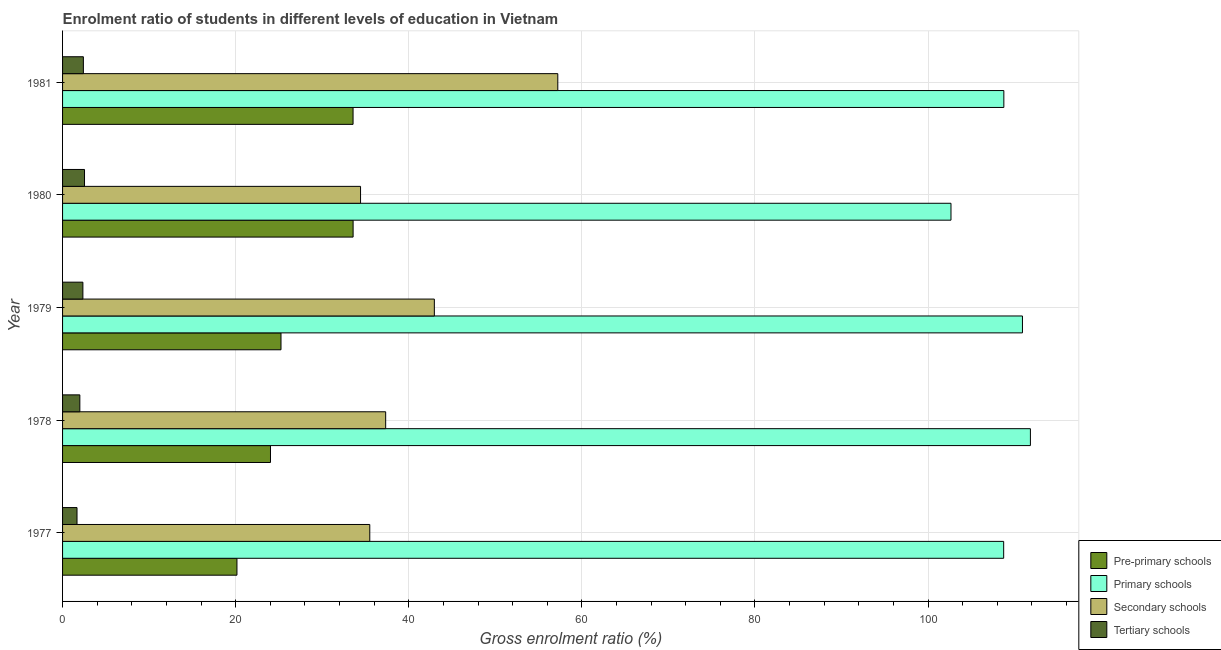How many groups of bars are there?
Your answer should be compact. 5. What is the label of the 3rd group of bars from the top?
Offer a very short reply. 1979. In how many cases, is the number of bars for a given year not equal to the number of legend labels?
Ensure brevity in your answer.  0. What is the gross enrolment ratio in primary schools in 1980?
Make the answer very short. 102.65. Across all years, what is the maximum gross enrolment ratio in pre-primary schools?
Offer a very short reply. 33.57. Across all years, what is the minimum gross enrolment ratio in primary schools?
Offer a terse response. 102.65. In which year was the gross enrolment ratio in secondary schools maximum?
Offer a terse response. 1981. What is the total gross enrolment ratio in pre-primary schools in the graph?
Your answer should be compact. 136.55. What is the difference between the gross enrolment ratio in primary schools in 1977 and that in 1978?
Offer a very short reply. -3.09. What is the difference between the gross enrolment ratio in tertiary schools in 1977 and the gross enrolment ratio in pre-primary schools in 1978?
Your answer should be very brief. -22.35. What is the average gross enrolment ratio in pre-primary schools per year?
Provide a short and direct response. 27.31. In the year 1979, what is the difference between the gross enrolment ratio in pre-primary schools and gross enrolment ratio in tertiary schools?
Provide a short and direct response. 22.89. What is the ratio of the gross enrolment ratio in pre-primary schools in 1980 to that in 1981?
Provide a short and direct response. 1. What is the difference between the highest and the second highest gross enrolment ratio in secondary schools?
Ensure brevity in your answer.  14.26. What is the difference between the highest and the lowest gross enrolment ratio in primary schools?
Your answer should be very brief. 9.18. In how many years, is the gross enrolment ratio in tertiary schools greater than the average gross enrolment ratio in tertiary schools taken over all years?
Keep it short and to the point. 3. Is the sum of the gross enrolment ratio in pre-primary schools in 1977 and 1980 greater than the maximum gross enrolment ratio in secondary schools across all years?
Provide a succinct answer. No. Is it the case that in every year, the sum of the gross enrolment ratio in secondary schools and gross enrolment ratio in tertiary schools is greater than the sum of gross enrolment ratio in pre-primary schools and gross enrolment ratio in primary schools?
Keep it short and to the point. No. What does the 2nd bar from the top in 1980 represents?
Your answer should be compact. Secondary schools. What does the 2nd bar from the bottom in 1980 represents?
Your response must be concise. Primary schools. How many bars are there?
Offer a very short reply. 20. How many years are there in the graph?
Ensure brevity in your answer.  5. What is the difference between two consecutive major ticks on the X-axis?
Provide a short and direct response. 20. Are the values on the major ticks of X-axis written in scientific E-notation?
Your answer should be compact. No. Does the graph contain any zero values?
Offer a very short reply. No. Does the graph contain grids?
Your answer should be very brief. Yes. How many legend labels are there?
Provide a short and direct response. 4. What is the title of the graph?
Keep it short and to the point. Enrolment ratio of students in different levels of education in Vietnam. Does "Coal" appear as one of the legend labels in the graph?
Provide a short and direct response. No. What is the label or title of the X-axis?
Your answer should be compact. Gross enrolment ratio (%). What is the Gross enrolment ratio (%) in Pre-primary schools in 1977?
Keep it short and to the point. 20.15. What is the Gross enrolment ratio (%) in Primary schools in 1977?
Offer a terse response. 108.74. What is the Gross enrolment ratio (%) of Secondary schools in 1977?
Offer a terse response. 35.5. What is the Gross enrolment ratio (%) in Tertiary schools in 1977?
Give a very brief answer. 1.67. What is the Gross enrolment ratio (%) in Pre-primary schools in 1978?
Your answer should be very brief. 24.02. What is the Gross enrolment ratio (%) in Primary schools in 1978?
Offer a terse response. 111.83. What is the Gross enrolment ratio (%) of Secondary schools in 1978?
Your answer should be compact. 37.33. What is the Gross enrolment ratio (%) of Tertiary schools in 1978?
Offer a terse response. 2. What is the Gross enrolment ratio (%) in Pre-primary schools in 1979?
Make the answer very short. 25.24. What is the Gross enrolment ratio (%) in Primary schools in 1979?
Your response must be concise. 110.91. What is the Gross enrolment ratio (%) of Secondary schools in 1979?
Your response must be concise. 42.96. What is the Gross enrolment ratio (%) of Tertiary schools in 1979?
Offer a very short reply. 2.35. What is the Gross enrolment ratio (%) of Pre-primary schools in 1980?
Offer a terse response. 33.57. What is the Gross enrolment ratio (%) of Primary schools in 1980?
Make the answer very short. 102.65. What is the Gross enrolment ratio (%) of Secondary schools in 1980?
Keep it short and to the point. 34.43. What is the Gross enrolment ratio (%) of Tertiary schools in 1980?
Keep it short and to the point. 2.54. What is the Gross enrolment ratio (%) in Pre-primary schools in 1981?
Your answer should be compact. 33.56. What is the Gross enrolment ratio (%) in Primary schools in 1981?
Make the answer very short. 108.76. What is the Gross enrolment ratio (%) in Secondary schools in 1981?
Make the answer very short. 57.22. What is the Gross enrolment ratio (%) in Tertiary schools in 1981?
Offer a very short reply. 2.4. Across all years, what is the maximum Gross enrolment ratio (%) of Pre-primary schools?
Ensure brevity in your answer.  33.57. Across all years, what is the maximum Gross enrolment ratio (%) of Primary schools?
Offer a terse response. 111.83. Across all years, what is the maximum Gross enrolment ratio (%) in Secondary schools?
Offer a very short reply. 57.22. Across all years, what is the maximum Gross enrolment ratio (%) in Tertiary schools?
Your answer should be compact. 2.54. Across all years, what is the minimum Gross enrolment ratio (%) in Pre-primary schools?
Ensure brevity in your answer.  20.15. Across all years, what is the minimum Gross enrolment ratio (%) in Primary schools?
Provide a short and direct response. 102.65. Across all years, what is the minimum Gross enrolment ratio (%) in Secondary schools?
Offer a terse response. 34.43. Across all years, what is the minimum Gross enrolment ratio (%) in Tertiary schools?
Keep it short and to the point. 1.67. What is the total Gross enrolment ratio (%) in Pre-primary schools in the graph?
Provide a succinct answer. 136.55. What is the total Gross enrolment ratio (%) of Primary schools in the graph?
Provide a short and direct response. 542.88. What is the total Gross enrolment ratio (%) of Secondary schools in the graph?
Provide a short and direct response. 207.44. What is the total Gross enrolment ratio (%) of Tertiary schools in the graph?
Provide a succinct answer. 10.95. What is the difference between the Gross enrolment ratio (%) of Pre-primary schools in 1977 and that in 1978?
Provide a succinct answer. -3.87. What is the difference between the Gross enrolment ratio (%) of Primary schools in 1977 and that in 1978?
Your response must be concise. -3.09. What is the difference between the Gross enrolment ratio (%) in Secondary schools in 1977 and that in 1978?
Give a very brief answer. -1.84. What is the difference between the Gross enrolment ratio (%) of Tertiary schools in 1977 and that in 1978?
Your answer should be very brief. -0.33. What is the difference between the Gross enrolment ratio (%) of Pre-primary schools in 1977 and that in 1979?
Offer a very short reply. -5.09. What is the difference between the Gross enrolment ratio (%) in Primary schools in 1977 and that in 1979?
Your answer should be compact. -2.17. What is the difference between the Gross enrolment ratio (%) of Secondary schools in 1977 and that in 1979?
Offer a terse response. -7.46. What is the difference between the Gross enrolment ratio (%) in Tertiary schools in 1977 and that in 1979?
Provide a short and direct response. -0.68. What is the difference between the Gross enrolment ratio (%) in Pre-primary schools in 1977 and that in 1980?
Your answer should be very brief. -13.42. What is the difference between the Gross enrolment ratio (%) of Primary schools in 1977 and that in 1980?
Ensure brevity in your answer.  6.09. What is the difference between the Gross enrolment ratio (%) in Secondary schools in 1977 and that in 1980?
Keep it short and to the point. 1.07. What is the difference between the Gross enrolment ratio (%) of Tertiary schools in 1977 and that in 1980?
Your response must be concise. -0.87. What is the difference between the Gross enrolment ratio (%) in Pre-primary schools in 1977 and that in 1981?
Your answer should be compact. -13.42. What is the difference between the Gross enrolment ratio (%) of Primary schools in 1977 and that in 1981?
Provide a short and direct response. -0.02. What is the difference between the Gross enrolment ratio (%) in Secondary schools in 1977 and that in 1981?
Your response must be concise. -21.72. What is the difference between the Gross enrolment ratio (%) of Tertiary schools in 1977 and that in 1981?
Provide a succinct answer. -0.73. What is the difference between the Gross enrolment ratio (%) in Pre-primary schools in 1978 and that in 1979?
Keep it short and to the point. -1.22. What is the difference between the Gross enrolment ratio (%) of Primary schools in 1978 and that in 1979?
Offer a terse response. 0.92. What is the difference between the Gross enrolment ratio (%) in Secondary schools in 1978 and that in 1979?
Offer a terse response. -5.62. What is the difference between the Gross enrolment ratio (%) in Tertiary schools in 1978 and that in 1979?
Provide a succinct answer. -0.35. What is the difference between the Gross enrolment ratio (%) in Pre-primary schools in 1978 and that in 1980?
Provide a succinct answer. -9.55. What is the difference between the Gross enrolment ratio (%) of Primary schools in 1978 and that in 1980?
Provide a short and direct response. 9.18. What is the difference between the Gross enrolment ratio (%) in Secondary schools in 1978 and that in 1980?
Offer a terse response. 2.9. What is the difference between the Gross enrolment ratio (%) in Tertiary schools in 1978 and that in 1980?
Give a very brief answer. -0.54. What is the difference between the Gross enrolment ratio (%) of Pre-primary schools in 1978 and that in 1981?
Give a very brief answer. -9.54. What is the difference between the Gross enrolment ratio (%) in Primary schools in 1978 and that in 1981?
Make the answer very short. 3.07. What is the difference between the Gross enrolment ratio (%) of Secondary schools in 1978 and that in 1981?
Offer a terse response. -19.89. What is the difference between the Gross enrolment ratio (%) of Tertiary schools in 1978 and that in 1981?
Your response must be concise. -0.41. What is the difference between the Gross enrolment ratio (%) in Pre-primary schools in 1979 and that in 1980?
Your response must be concise. -8.33. What is the difference between the Gross enrolment ratio (%) in Primary schools in 1979 and that in 1980?
Offer a terse response. 8.26. What is the difference between the Gross enrolment ratio (%) in Secondary schools in 1979 and that in 1980?
Offer a very short reply. 8.53. What is the difference between the Gross enrolment ratio (%) of Tertiary schools in 1979 and that in 1980?
Offer a terse response. -0.19. What is the difference between the Gross enrolment ratio (%) in Pre-primary schools in 1979 and that in 1981?
Keep it short and to the point. -8.33. What is the difference between the Gross enrolment ratio (%) in Primary schools in 1979 and that in 1981?
Your answer should be very brief. 2.15. What is the difference between the Gross enrolment ratio (%) in Secondary schools in 1979 and that in 1981?
Offer a terse response. -14.26. What is the difference between the Gross enrolment ratio (%) of Tertiary schools in 1979 and that in 1981?
Offer a very short reply. -0.05. What is the difference between the Gross enrolment ratio (%) of Pre-primary schools in 1980 and that in 1981?
Offer a very short reply. 0.01. What is the difference between the Gross enrolment ratio (%) of Primary schools in 1980 and that in 1981?
Give a very brief answer. -6.11. What is the difference between the Gross enrolment ratio (%) of Secondary schools in 1980 and that in 1981?
Your answer should be compact. -22.79. What is the difference between the Gross enrolment ratio (%) in Tertiary schools in 1980 and that in 1981?
Ensure brevity in your answer.  0.13. What is the difference between the Gross enrolment ratio (%) in Pre-primary schools in 1977 and the Gross enrolment ratio (%) in Primary schools in 1978?
Give a very brief answer. -91.68. What is the difference between the Gross enrolment ratio (%) of Pre-primary schools in 1977 and the Gross enrolment ratio (%) of Secondary schools in 1978?
Offer a very short reply. -17.18. What is the difference between the Gross enrolment ratio (%) of Pre-primary schools in 1977 and the Gross enrolment ratio (%) of Tertiary schools in 1978?
Provide a succinct answer. 18.15. What is the difference between the Gross enrolment ratio (%) in Primary schools in 1977 and the Gross enrolment ratio (%) in Secondary schools in 1978?
Provide a succinct answer. 71.41. What is the difference between the Gross enrolment ratio (%) of Primary schools in 1977 and the Gross enrolment ratio (%) of Tertiary schools in 1978?
Offer a terse response. 106.74. What is the difference between the Gross enrolment ratio (%) of Secondary schools in 1977 and the Gross enrolment ratio (%) of Tertiary schools in 1978?
Offer a terse response. 33.5. What is the difference between the Gross enrolment ratio (%) in Pre-primary schools in 1977 and the Gross enrolment ratio (%) in Primary schools in 1979?
Your response must be concise. -90.76. What is the difference between the Gross enrolment ratio (%) of Pre-primary schools in 1977 and the Gross enrolment ratio (%) of Secondary schools in 1979?
Offer a terse response. -22.81. What is the difference between the Gross enrolment ratio (%) in Pre-primary schools in 1977 and the Gross enrolment ratio (%) in Tertiary schools in 1979?
Give a very brief answer. 17.8. What is the difference between the Gross enrolment ratio (%) of Primary schools in 1977 and the Gross enrolment ratio (%) of Secondary schools in 1979?
Keep it short and to the point. 65.78. What is the difference between the Gross enrolment ratio (%) in Primary schools in 1977 and the Gross enrolment ratio (%) in Tertiary schools in 1979?
Offer a very short reply. 106.39. What is the difference between the Gross enrolment ratio (%) in Secondary schools in 1977 and the Gross enrolment ratio (%) in Tertiary schools in 1979?
Provide a short and direct response. 33.15. What is the difference between the Gross enrolment ratio (%) in Pre-primary schools in 1977 and the Gross enrolment ratio (%) in Primary schools in 1980?
Your response must be concise. -82.5. What is the difference between the Gross enrolment ratio (%) in Pre-primary schools in 1977 and the Gross enrolment ratio (%) in Secondary schools in 1980?
Ensure brevity in your answer.  -14.28. What is the difference between the Gross enrolment ratio (%) in Pre-primary schools in 1977 and the Gross enrolment ratio (%) in Tertiary schools in 1980?
Your response must be concise. 17.61. What is the difference between the Gross enrolment ratio (%) in Primary schools in 1977 and the Gross enrolment ratio (%) in Secondary schools in 1980?
Ensure brevity in your answer.  74.31. What is the difference between the Gross enrolment ratio (%) of Primary schools in 1977 and the Gross enrolment ratio (%) of Tertiary schools in 1980?
Offer a very short reply. 106.2. What is the difference between the Gross enrolment ratio (%) of Secondary schools in 1977 and the Gross enrolment ratio (%) of Tertiary schools in 1980?
Keep it short and to the point. 32.96. What is the difference between the Gross enrolment ratio (%) of Pre-primary schools in 1977 and the Gross enrolment ratio (%) of Primary schools in 1981?
Your answer should be compact. -88.61. What is the difference between the Gross enrolment ratio (%) in Pre-primary schools in 1977 and the Gross enrolment ratio (%) in Secondary schools in 1981?
Provide a short and direct response. -37.07. What is the difference between the Gross enrolment ratio (%) in Pre-primary schools in 1977 and the Gross enrolment ratio (%) in Tertiary schools in 1981?
Make the answer very short. 17.75. What is the difference between the Gross enrolment ratio (%) of Primary schools in 1977 and the Gross enrolment ratio (%) of Secondary schools in 1981?
Offer a very short reply. 51.52. What is the difference between the Gross enrolment ratio (%) in Primary schools in 1977 and the Gross enrolment ratio (%) in Tertiary schools in 1981?
Provide a short and direct response. 106.33. What is the difference between the Gross enrolment ratio (%) in Secondary schools in 1977 and the Gross enrolment ratio (%) in Tertiary schools in 1981?
Your answer should be compact. 33.09. What is the difference between the Gross enrolment ratio (%) of Pre-primary schools in 1978 and the Gross enrolment ratio (%) of Primary schools in 1979?
Keep it short and to the point. -86.88. What is the difference between the Gross enrolment ratio (%) of Pre-primary schools in 1978 and the Gross enrolment ratio (%) of Secondary schools in 1979?
Your response must be concise. -18.93. What is the difference between the Gross enrolment ratio (%) in Pre-primary schools in 1978 and the Gross enrolment ratio (%) in Tertiary schools in 1979?
Give a very brief answer. 21.67. What is the difference between the Gross enrolment ratio (%) of Primary schools in 1978 and the Gross enrolment ratio (%) of Secondary schools in 1979?
Ensure brevity in your answer.  68.87. What is the difference between the Gross enrolment ratio (%) in Primary schools in 1978 and the Gross enrolment ratio (%) in Tertiary schools in 1979?
Your answer should be compact. 109.48. What is the difference between the Gross enrolment ratio (%) of Secondary schools in 1978 and the Gross enrolment ratio (%) of Tertiary schools in 1979?
Your answer should be very brief. 34.98. What is the difference between the Gross enrolment ratio (%) in Pre-primary schools in 1978 and the Gross enrolment ratio (%) in Primary schools in 1980?
Provide a short and direct response. -78.63. What is the difference between the Gross enrolment ratio (%) in Pre-primary schools in 1978 and the Gross enrolment ratio (%) in Secondary schools in 1980?
Provide a short and direct response. -10.41. What is the difference between the Gross enrolment ratio (%) of Pre-primary schools in 1978 and the Gross enrolment ratio (%) of Tertiary schools in 1980?
Offer a terse response. 21.49. What is the difference between the Gross enrolment ratio (%) of Primary schools in 1978 and the Gross enrolment ratio (%) of Secondary schools in 1980?
Make the answer very short. 77.4. What is the difference between the Gross enrolment ratio (%) of Primary schools in 1978 and the Gross enrolment ratio (%) of Tertiary schools in 1980?
Offer a very short reply. 109.29. What is the difference between the Gross enrolment ratio (%) in Secondary schools in 1978 and the Gross enrolment ratio (%) in Tertiary schools in 1980?
Your response must be concise. 34.8. What is the difference between the Gross enrolment ratio (%) in Pre-primary schools in 1978 and the Gross enrolment ratio (%) in Primary schools in 1981?
Your answer should be very brief. -84.73. What is the difference between the Gross enrolment ratio (%) of Pre-primary schools in 1978 and the Gross enrolment ratio (%) of Secondary schools in 1981?
Ensure brevity in your answer.  -33.2. What is the difference between the Gross enrolment ratio (%) of Pre-primary schools in 1978 and the Gross enrolment ratio (%) of Tertiary schools in 1981?
Your answer should be compact. 21.62. What is the difference between the Gross enrolment ratio (%) in Primary schools in 1978 and the Gross enrolment ratio (%) in Secondary schools in 1981?
Keep it short and to the point. 54.61. What is the difference between the Gross enrolment ratio (%) in Primary schools in 1978 and the Gross enrolment ratio (%) in Tertiary schools in 1981?
Give a very brief answer. 109.42. What is the difference between the Gross enrolment ratio (%) in Secondary schools in 1978 and the Gross enrolment ratio (%) in Tertiary schools in 1981?
Ensure brevity in your answer.  34.93. What is the difference between the Gross enrolment ratio (%) in Pre-primary schools in 1979 and the Gross enrolment ratio (%) in Primary schools in 1980?
Make the answer very short. -77.41. What is the difference between the Gross enrolment ratio (%) of Pre-primary schools in 1979 and the Gross enrolment ratio (%) of Secondary schools in 1980?
Provide a short and direct response. -9.19. What is the difference between the Gross enrolment ratio (%) in Pre-primary schools in 1979 and the Gross enrolment ratio (%) in Tertiary schools in 1980?
Give a very brief answer. 22.7. What is the difference between the Gross enrolment ratio (%) in Primary schools in 1979 and the Gross enrolment ratio (%) in Secondary schools in 1980?
Provide a short and direct response. 76.48. What is the difference between the Gross enrolment ratio (%) in Primary schools in 1979 and the Gross enrolment ratio (%) in Tertiary schools in 1980?
Offer a very short reply. 108.37. What is the difference between the Gross enrolment ratio (%) of Secondary schools in 1979 and the Gross enrolment ratio (%) of Tertiary schools in 1980?
Your response must be concise. 40.42. What is the difference between the Gross enrolment ratio (%) in Pre-primary schools in 1979 and the Gross enrolment ratio (%) in Primary schools in 1981?
Offer a very short reply. -83.52. What is the difference between the Gross enrolment ratio (%) in Pre-primary schools in 1979 and the Gross enrolment ratio (%) in Secondary schools in 1981?
Provide a succinct answer. -31.98. What is the difference between the Gross enrolment ratio (%) in Pre-primary schools in 1979 and the Gross enrolment ratio (%) in Tertiary schools in 1981?
Offer a very short reply. 22.83. What is the difference between the Gross enrolment ratio (%) in Primary schools in 1979 and the Gross enrolment ratio (%) in Secondary schools in 1981?
Make the answer very short. 53.69. What is the difference between the Gross enrolment ratio (%) in Primary schools in 1979 and the Gross enrolment ratio (%) in Tertiary schools in 1981?
Give a very brief answer. 108.5. What is the difference between the Gross enrolment ratio (%) in Secondary schools in 1979 and the Gross enrolment ratio (%) in Tertiary schools in 1981?
Your answer should be compact. 40.55. What is the difference between the Gross enrolment ratio (%) of Pre-primary schools in 1980 and the Gross enrolment ratio (%) of Primary schools in 1981?
Your answer should be compact. -75.19. What is the difference between the Gross enrolment ratio (%) of Pre-primary schools in 1980 and the Gross enrolment ratio (%) of Secondary schools in 1981?
Give a very brief answer. -23.65. What is the difference between the Gross enrolment ratio (%) of Pre-primary schools in 1980 and the Gross enrolment ratio (%) of Tertiary schools in 1981?
Keep it short and to the point. 31.17. What is the difference between the Gross enrolment ratio (%) of Primary schools in 1980 and the Gross enrolment ratio (%) of Secondary schools in 1981?
Your response must be concise. 45.43. What is the difference between the Gross enrolment ratio (%) of Primary schools in 1980 and the Gross enrolment ratio (%) of Tertiary schools in 1981?
Your answer should be very brief. 100.25. What is the difference between the Gross enrolment ratio (%) in Secondary schools in 1980 and the Gross enrolment ratio (%) in Tertiary schools in 1981?
Offer a very short reply. 32.03. What is the average Gross enrolment ratio (%) in Pre-primary schools per year?
Provide a short and direct response. 27.31. What is the average Gross enrolment ratio (%) in Primary schools per year?
Your response must be concise. 108.58. What is the average Gross enrolment ratio (%) in Secondary schools per year?
Your response must be concise. 41.49. What is the average Gross enrolment ratio (%) in Tertiary schools per year?
Offer a very short reply. 2.19. In the year 1977, what is the difference between the Gross enrolment ratio (%) of Pre-primary schools and Gross enrolment ratio (%) of Primary schools?
Provide a succinct answer. -88.59. In the year 1977, what is the difference between the Gross enrolment ratio (%) of Pre-primary schools and Gross enrolment ratio (%) of Secondary schools?
Your answer should be very brief. -15.35. In the year 1977, what is the difference between the Gross enrolment ratio (%) in Pre-primary schools and Gross enrolment ratio (%) in Tertiary schools?
Give a very brief answer. 18.48. In the year 1977, what is the difference between the Gross enrolment ratio (%) in Primary schools and Gross enrolment ratio (%) in Secondary schools?
Your answer should be very brief. 73.24. In the year 1977, what is the difference between the Gross enrolment ratio (%) in Primary schools and Gross enrolment ratio (%) in Tertiary schools?
Your answer should be compact. 107.07. In the year 1977, what is the difference between the Gross enrolment ratio (%) of Secondary schools and Gross enrolment ratio (%) of Tertiary schools?
Provide a succinct answer. 33.83. In the year 1978, what is the difference between the Gross enrolment ratio (%) in Pre-primary schools and Gross enrolment ratio (%) in Primary schools?
Your answer should be compact. -87.8. In the year 1978, what is the difference between the Gross enrolment ratio (%) of Pre-primary schools and Gross enrolment ratio (%) of Secondary schools?
Your answer should be very brief. -13.31. In the year 1978, what is the difference between the Gross enrolment ratio (%) of Pre-primary schools and Gross enrolment ratio (%) of Tertiary schools?
Offer a very short reply. 22.03. In the year 1978, what is the difference between the Gross enrolment ratio (%) of Primary schools and Gross enrolment ratio (%) of Secondary schools?
Your answer should be very brief. 74.5. In the year 1978, what is the difference between the Gross enrolment ratio (%) of Primary schools and Gross enrolment ratio (%) of Tertiary schools?
Offer a very short reply. 109.83. In the year 1978, what is the difference between the Gross enrolment ratio (%) in Secondary schools and Gross enrolment ratio (%) in Tertiary schools?
Your response must be concise. 35.34. In the year 1979, what is the difference between the Gross enrolment ratio (%) of Pre-primary schools and Gross enrolment ratio (%) of Primary schools?
Your answer should be very brief. -85.67. In the year 1979, what is the difference between the Gross enrolment ratio (%) of Pre-primary schools and Gross enrolment ratio (%) of Secondary schools?
Your answer should be very brief. -17.72. In the year 1979, what is the difference between the Gross enrolment ratio (%) of Pre-primary schools and Gross enrolment ratio (%) of Tertiary schools?
Ensure brevity in your answer.  22.89. In the year 1979, what is the difference between the Gross enrolment ratio (%) of Primary schools and Gross enrolment ratio (%) of Secondary schools?
Offer a terse response. 67.95. In the year 1979, what is the difference between the Gross enrolment ratio (%) of Primary schools and Gross enrolment ratio (%) of Tertiary schools?
Provide a succinct answer. 108.56. In the year 1979, what is the difference between the Gross enrolment ratio (%) of Secondary schools and Gross enrolment ratio (%) of Tertiary schools?
Your answer should be compact. 40.61. In the year 1980, what is the difference between the Gross enrolment ratio (%) in Pre-primary schools and Gross enrolment ratio (%) in Primary schools?
Provide a short and direct response. -69.08. In the year 1980, what is the difference between the Gross enrolment ratio (%) in Pre-primary schools and Gross enrolment ratio (%) in Secondary schools?
Make the answer very short. -0.86. In the year 1980, what is the difference between the Gross enrolment ratio (%) of Pre-primary schools and Gross enrolment ratio (%) of Tertiary schools?
Make the answer very short. 31.03. In the year 1980, what is the difference between the Gross enrolment ratio (%) of Primary schools and Gross enrolment ratio (%) of Secondary schools?
Your answer should be compact. 68.22. In the year 1980, what is the difference between the Gross enrolment ratio (%) in Primary schools and Gross enrolment ratio (%) in Tertiary schools?
Provide a short and direct response. 100.11. In the year 1980, what is the difference between the Gross enrolment ratio (%) of Secondary schools and Gross enrolment ratio (%) of Tertiary schools?
Your answer should be very brief. 31.89. In the year 1981, what is the difference between the Gross enrolment ratio (%) in Pre-primary schools and Gross enrolment ratio (%) in Primary schools?
Give a very brief answer. -75.19. In the year 1981, what is the difference between the Gross enrolment ratio (%) of Pre-primary schools and Gross enrolment ratio (%) of Secondary schools?
Your answer should be compact. -23.66. In the year 1981, what is the difference between the Gross enrolment ratio (%) of Pre-primary schools and Gross enrolment ratio (%) of Tertiary schools?
Ensure brevity in your answer.  31.16. In the year 1981, what is the difference between the Gross enrolment ratio (%) in Primary schools and Gross enrolment ratio (%) in Secondary schools?
Your answer should be compact. 51.54. In the year 1981, what is the difference between the Gross enrolment ratio (%) of Primary schools and Gross enrolment ratio (%) of Tertiary schools?
Provide a short and direct response. 106.35. In the year 1981, what is the difference between the Gross enrolment ratio (%) in Secondary schools and Gross enrolment ratio (%) in Tertiary schools?
Offer a terse response. 54.82. What is the ratio of the Gross enrolment ratio (%) in Pre-primary schools in 1977 to that in 1978?
Provide a succinct answer. 0.84. What is the ratio of the Gross enrolment ratio (%) in Primary schools in 1977 to that in 1978?
Give a very brief answer. 0.97. What is the ratio of the Gross enrolment ratio (%) of Secondary schools in 1977 to that in 1978?
Ensure brevity in your answer.  0.95. What is the ratio of the Gross enrolment ratio (%) in Tertiary schools in 1977 to that in 1978?
Ensure brevity in your answer.  0.84. What is the ratio of the Gross enrolment ratio (%) in Pre-primary schools in 1977 to that in 1979?
Keep it short and to the point. 0.8. What is the ratio of the Gross enrolment ratio (%) in Primary schools in 1977 to that in 1979?
Make the answer very short. 0.98. What is the ratio of the Gross enrolment ratio (%) in Secondary schools in 1977 to that in 1979?
Your response must be concise. 0.83. What is the ratio of the Gross enrolment ratio (%) in Tertiary schools in 1977 to that in 1979?
Your answer should be very brief. 0.71. What is the ratio of the Gross enrolment ratio (%) in Pre-primary schools in 1977 to that in 1980?
Your answer should be very brief. 0.6. What is the ratio of the Gross enrolment ratio (%) in Primary schools in 1977 to that in 1980?
Provide a succinct answer. 1.06. What is the ratio of the Gross enrolment ratio (%) of Secondary schools in 1977 to that in 1980?
Make the answer very short. 1.03. What is the ratio of the Gross enrolment ratio (%) of Tertiary schools in 1977 to that in 1980?
Provide a succinct answer. 0.66. What is the ratio of the Gross enrolment ratio (%) of Pre-primary schools in 1977 to that in 1981?
Offer a very short reply. 0.6. What is the ratio of the Gross enrolment ratio (%) of Secondary schools in 1977 to that in 1981?
Offer a very short reply. 0.62. What is the ratio of the Gross enrolment ratio (%) of Tertiary schools in 1977 to that in 1981?
Make the answer very short. 0.69. What is the ratio of the Gross enrolment ratio (%) of Pre-primary schools in 1978 to that in 1979?
Offer a very short reply. 0.95. What is the ratio of the Gross enrolment ratio (%) in Primary schools in 1978 to that in 1979?
Your answer should be compact. 1.01. What is the ratio of the Gross enrolment ratio (%) of Secondary schools in 1978 to that in 1979?
Offer a very short reply. 0.87. What is the ratio of the Gross enrolment ratio (%) of Tertiary schools in 1978 to that in 1979?
Provide a succinct answer. 0.85. What is the ratio of the Gross enrolment ratio (%) of Pre-primary schools in 1978 to that in 1980?
Your answer should be very brief. 0.72. What is the ratio of the Gross enrolment ratio (%) of Primary schools in 1978 to that in 1980?
Ensure brevity in your answer.  1.09. What is the ratio of the Gross enrolment ratio (%) of Secondary schools in 1978 to that in 1980?
Give a very brief answer. 1.08. What is the ratio of the Gross enrolment ratio (%) in Tertiary schools in 1978 to that in 1980?
Ensure brevity in your answer.  0.79. What is the ratio of the Gross enrolment ratio (%) of Pre-primary schools in 1978 to that in 1981?
Keep it short and to the point. 0.72. What is the ratio of the Gross enrolment ratio (%) in Primary schools in 1978 to that in 1981?
Provide a succinct answer. 1.03. What is the ratio of the Gross enrolment ratio (%) of Secondary schools in 1978 to that in 1981?
Your response must be concise. 0.65. What is the ratio of the Gross enrolment ratio (%) in Tertiary schools in 1978 to that in 1981?
Give a very brief answer. 0.83. What is the ratio of the Gross enrolment ratio (%) in Pre-primary schools in 1979 to that in 1980?
Offer a very short reply. 0.75. What is the ratio of the Gross enrolment ratio (%) of Primary schools in 1979 to that in 1980?
Your answer should be compact. 1.08. What is the ratio of the Gross enrolment ratio (%) in Secondary schools in 1979 to that in 1980?
Offer a very short reply. 1.25. What is the ratio of the Gross enrolment ratio (%) of Tertiary schools in 1979 to that in 1980?
Provide a short and direct response. 0.93. What is the ratio of the Gross enrolment ratio (%) of Pre-primary schools in 1979 to that in 1981?
Your answer should be very brief. 0.75. What is the ratio of the Gross enrolment ratio (%) of Primary schools in 1979 to that in 1981?
Make the answer very short. 1.02. What is the ratio of the Gross enrolment ratio (%) of Secondary schools in 1979 to that in 1981?
Ensure brevity in your answer.  0.75. What is the ratio of the Gross enrolment ratio (%) of Tertiary schools in 1979 to that in 1981?
Give a very brief answer. 0.98. What is the ratio of the Gross enrolment ratio (%) of Pre-primary schools in 1980 to that in 1981?
Your response must be concise. 1. What is the ratio of the Gross enrolment ratio (%) of Primary schools in 1980 to that in 1981?
Provide a succinct answer. 0.94. What is the ratio of the Gross enrolment ratio (%) of Secondary schools in 1980 to that in 1981?
Give a very brief answer. 0.6. What is the ratio of the Gross enrolment ratio (%) in Tertiary schools in 1980 to that in 1981?
Your answer should be very brief. 1.06. What is the difference between the highest and the second highest Gross enrolment ratio (%) of Pre-primary schools?
Offer a terse response. 0.01. What is the difference between the highest and the second highest Gross enrolment ratio (%) in Primary schools?
Provide a short and direct response. 0.92. What is the difference between the highest and the second highest Gross enrolment ratio (%) in Secondary schools?
Your answer should be very brief. 14.26. What is the difference between the highest and the second highest Gross enrolment ratio (%) of Tertiary schools?
Ensure brevity in your answer.  0.13. What is the difference between the highest and the lowest Gross enrolment ratio (%) in Pre-primary schools?
Provide a succinct answer. 13.42. What is the difference between the highest and the lowest Gross enrolment ratio (%) of Primary schools?
Ensure brevity in your answer.  9.18. What is the difference between the highest and the lowest Gross enrolment ratio (%) of Secondary schools?
Give a very brief answer. 22.79. What is the difference between the highest and the lowest Gross enrolment ratio (%) in Tertiary schools?
Keep it short and to the point. 0.87. 